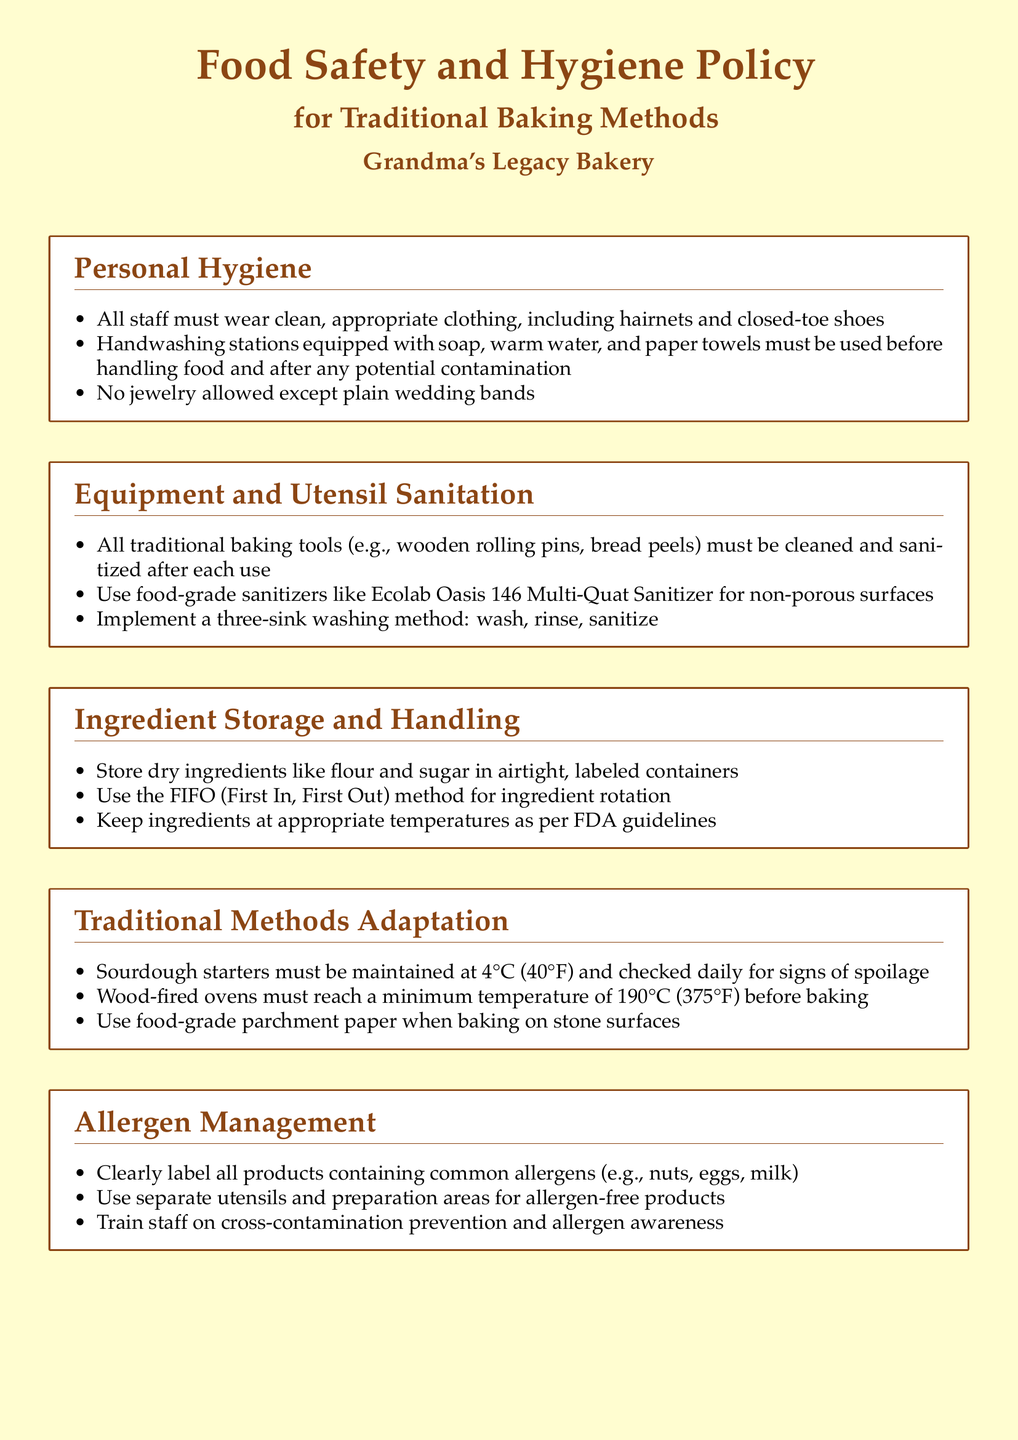What is the maximum temperature for wood-fired ovens? The maximum temperature that wood-fired ovens must reach before baking is mentioned in the Traditional Methods Adaptation section.
Answer: 190°C What storage method is recommended for dry ingredients? The recommended storage method for dry ingredients like flour and sugar is found in the Ingredient Storage and Handling section.
Answer: Airtight, labeled containers What is required for allergen management? The requirements for allergen management can be found in the Allergen Management section, emphasizing the importance of product labeling.
Answer: Clearly label all products How often should food safety training sessions be conducted? The frequency of food safety training sessions for employees is indicated in the Documentation and Training section.
Answer: Monthly What type of sanitizer should be used on non-porous surfaces? The specific type of sanitizer for non-porous surfaces is listed in the Equipment and Utensil Sanitation section.
Answer: Ecolab Oasis 146 Multi-Quat Sanitizer What must all staff wear for personal hygiene? The required clothing and accessories for personal hygiene are specified in the Personal Hygiene section.
Answer: Clean, appropriate clothing, hairnets, and closed-toe shoes What method should be implemented for washing equipment? The method for washing equipment is explained in the Equipment and Utensil Sanitation section.
Answer: Three-sink washing method What is the required storage temperature for sourdough starters? The required temperature for maintaining sourdough starters is detailed in the Traditional Methods Adaptation section.
Answer: 4°C 